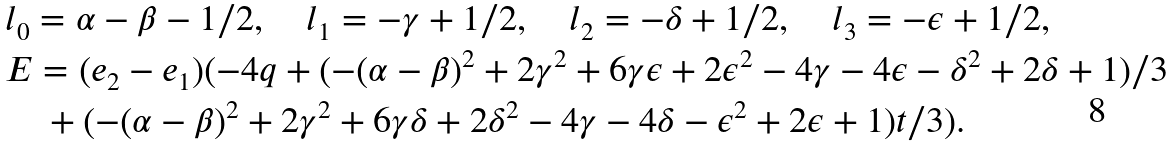<formula> <loc_0><loc_0><loc_500><loc_500>& l _ { 0 } = \alpha - \beta - 1 / 2 , \quad l _ { 1 } = - \gamma + 1 / 2 , \quad l _ { 2 } = - \delta + 1 / 2 , \quad l _ { 3 } = - \epsilon + 1 / 2 , \\ & E = ( e _ { 2 } - e _ { 1 } ) ( - 4 q + ( - ( \alpha - \beta ) ^ { 2 } + 2 \gamma ^ { 2 } + 6 \gamma \epsilon + 2 \epsilon ^ { 2 } - 4 \gamma - 4 \epsilon - \delta ^ { 2 } + 2 \delta + 1 ) / 3 \\ & \quad + ( - ( \alpha - \beta ) ^ { 2 } + 2 \gamma ^ { 2 } + 6 \gamma \delta + 2 \delta ^ { 2 } - 4 \gamma - 4 \delta - \epsilon ^ { 2 } + 2 \epsilon + 1 ) t / 3 ) .</formula> 